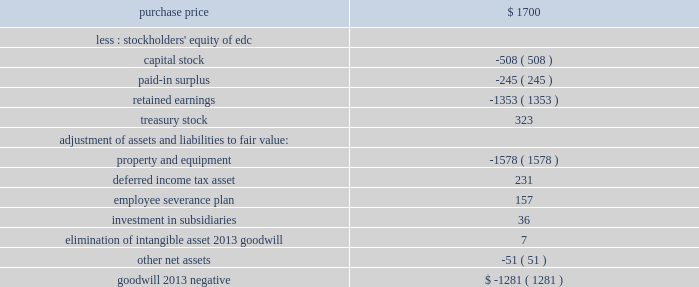Over 1 million customers .
Edc also provides 2265 mw of installed capacity through its generation facilities in venezuela .
The purchase price allocation was as follows ( in millions ) : .
Property and equipment was reduced by the negative goodwill .
The cost of the acquisition was allocated on the basis of estimated fair value of the assets acquired and liabilities assumed , primarily based upon an independent appraisal .
As of december 31 , 2000 , the severance plan was completed and the workforce was reduced by approximately 2500 people .
All of the costs associated with the plan were recorded during 2000 , and all of the cash payments were made in 2000 .
In august 2000 , a subsidiary of the company completed the acquisition of a 59% ( 59 % ) equity interest in a hidroelectrica alicura s.a .
( 2018 2018alicura 2019 2019 ) in argentina from southern energy , inc .
And its partners .
Alicura operates a 1000 mw peaking hydro facility located in the province of neuquen , argentina .
The purchase price of approximately $ 205 million includes the assumption of existing non-recourse debt .
In december 2000 a subsidiary of the company acquired an additional 39% ( 39 % ) ownership interest in alicura , 19.5% ( 19.5 % ) ownership interests each from the federal government of argentina and the province of neuquen , for approximately $ 9 million .
At december 31 , 2000 , the company 2019s ownership interest was 98% ( 98 % ) .
The employees of alicura own the remaining 2% ( 2 % ) .
All of the purchase price was allocated to property , plant and equipment and is being depreciated over the useful life .
In october 2000 , a subsidiary of the company completed the acquisition of reliant energy international 2019s 50% ( 50 % ) interest in el salvador energy holdings , s.a .
( 2018 2018eseh 2019 2019 ) that owns three distribution companies in el salvador .
The purchase price for this interest in eseh was approximately $ 173 million .
The three distribution companies , compania de alumbrado electrico de san salvador , s.a .
De c.v. , empresa electrica de oriente , s.a .
De c.v .
And distribuidora electrica de usulutan , s.a .
De c.v .
Serve 3.5 million people , approximately 60% ( 60 % ) of the population of el salvador , including the capital city of san salvador .
A subsidiary of the company had previously acquired a 50% ( 50 % ) interest in eseh through its acquisition of edc .
Through the purchase of reliant energy international 2019s ownership interest , the company owns a controlling interest in the three distribution companies .
The total purchase price for 100% ( 100 % ) of the interest in eseh approximated $ 325 million , of which approximately $ 176 million was allocated to goodwill and is being amortized over 40 years .
In december 2000 , the company acquired all of the outstanding shares of kmr power corporation ( 2018 2018kmr 2019 2019 ) , including the buyout of a minority partner in one of kmr 2019s subsidiaries , for approximately $ 64 million and assumed long-term liabilities of approximately $ 245 million .
The acquisition was financed through the issuance of approximately 699000 shares of aes common stock and cash .
Kmr owns a controlling interest in two gas-fired power plants located in cartagena , colombia : a 100% ( 100 % ) interest in the 314 mw termocandelaria power plant and a 66% ( 66 % ) interest in the 100 .
What was the total price for the kmr power corporation purchase in millions? 
Rationale: cash paid plus the assumed debt is the actual price .
Computations: (64 + 245)
Answer: 309.0. 